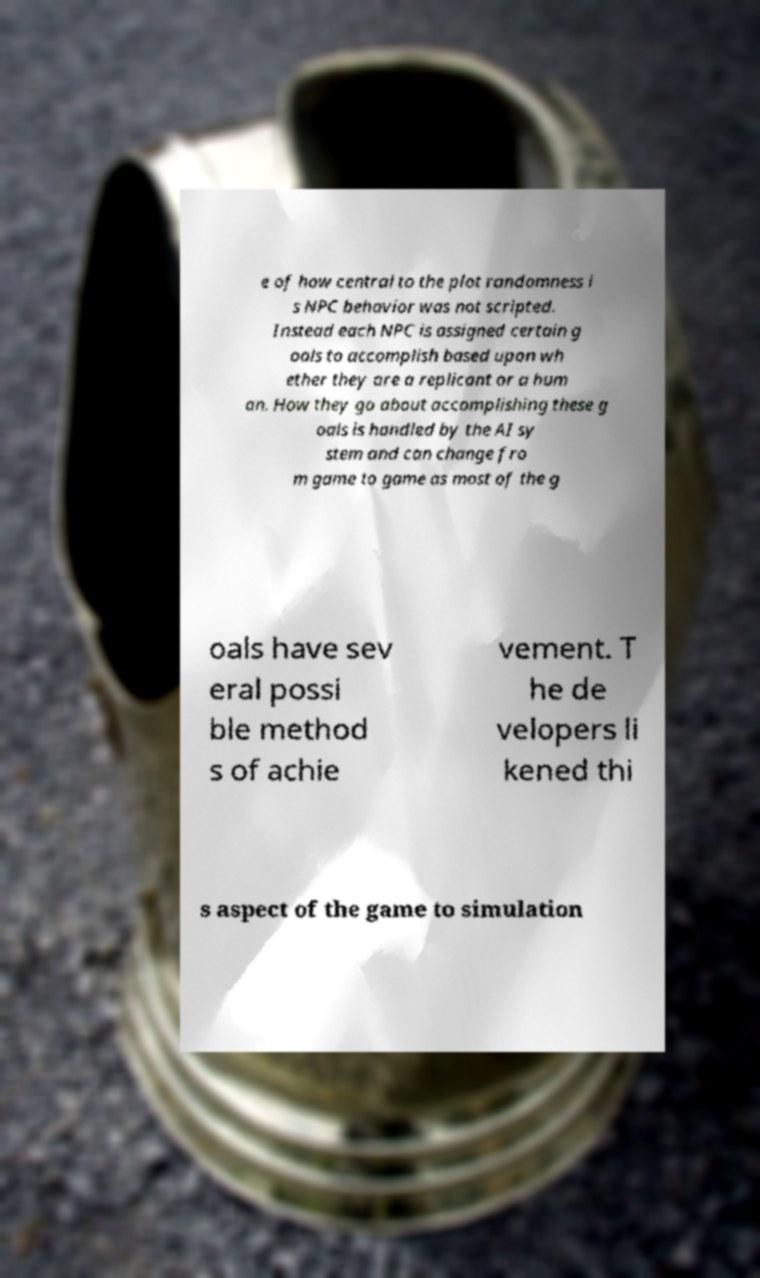There's text embedded in this image that I need extracted. Can you transcribe it verbatim? e of how central to the plot randomness i s NPC behavior was not scripted. Instead each NPC is assigned certain g oals to accomplish based upon wh ether they are a replicant or a hum an. How they go about accomplishing these g oals is handled by the AI sy stem and can change fro m game to game as most of the g oals have sev eral possi ble method s of achie vement. T he de velopers li kened thi s aspect of the game to simulation 